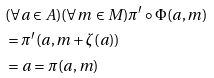Convert formula to latex. <formula><loc_0><loc_0><loc_500><loc_500>& ( \forall a \in A ) ( \forall m \in M ) \pi ^ { \prime } \circ \Phi ( a , m ) \\ & = \pi ^ { \prime } ( a , m + \zeta ( a ) ) \\ & = a = \pi ( a , m )</formula> 